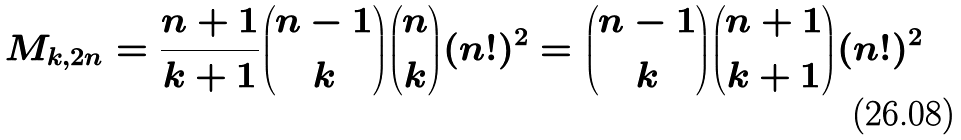<formula> <loc_0><loc_0><loc_500><loc_500>M _ { k , 2 n } = \frac { n + 1 } { k + 1 } \binom { n - 1 } { k } \binom { n } { k } ( n ! ) ^ { 2 } = \binom { n - 1 } { k } \binom { n + 1 } { k + 1 } ( n ! ) ^ { 2 }</formula> 